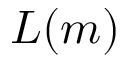<formula> <loc_0><loc_0><loc_500><loc_500>L ( m )</formula> 